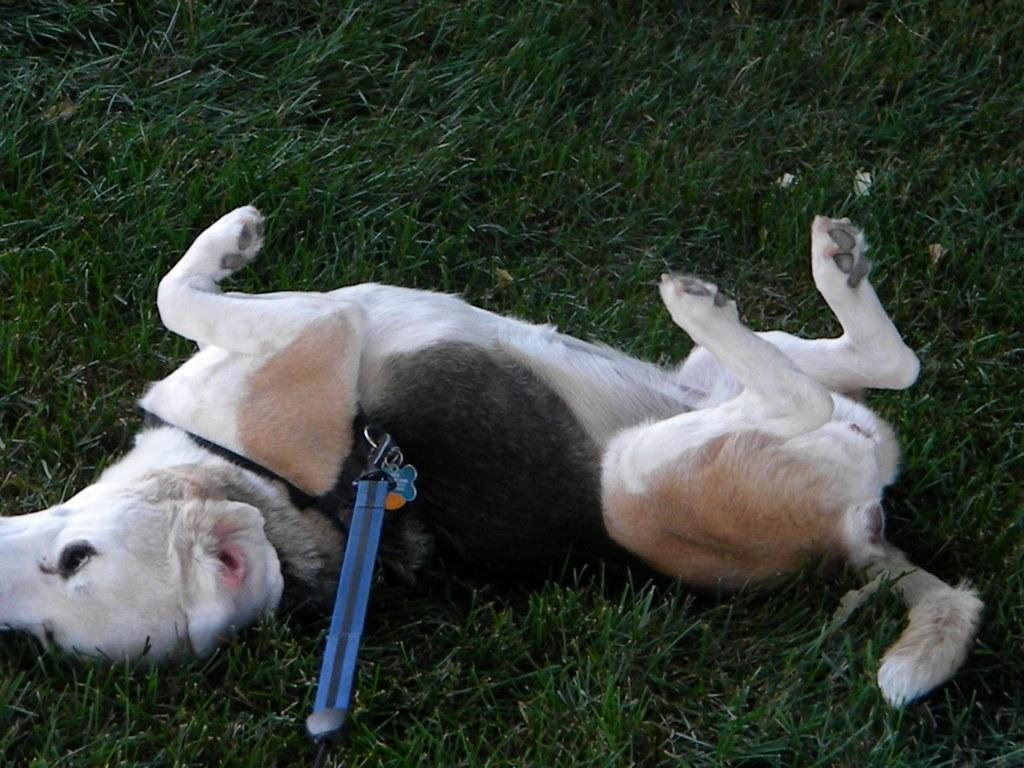What type of surface is visible on the ground in the image? There is grass on the ground in the image. What animal can be seen in the image? There is a dog lying on the grass in the image. Does the dog have any accessories in the image? Yes, the dog has a collar in the image. What color is the object on the dog's collar? The object on the dog's collar has a blue color. How many dolls are sitting on the grass with the dog in the image? There are no dolls present in the image; it only features a dog lying on the grass. What is the condition of the grass in the image? The condition of the grass cannot be determined from the image alone, as it only shows the presence of grass without any specific details about its condition. 